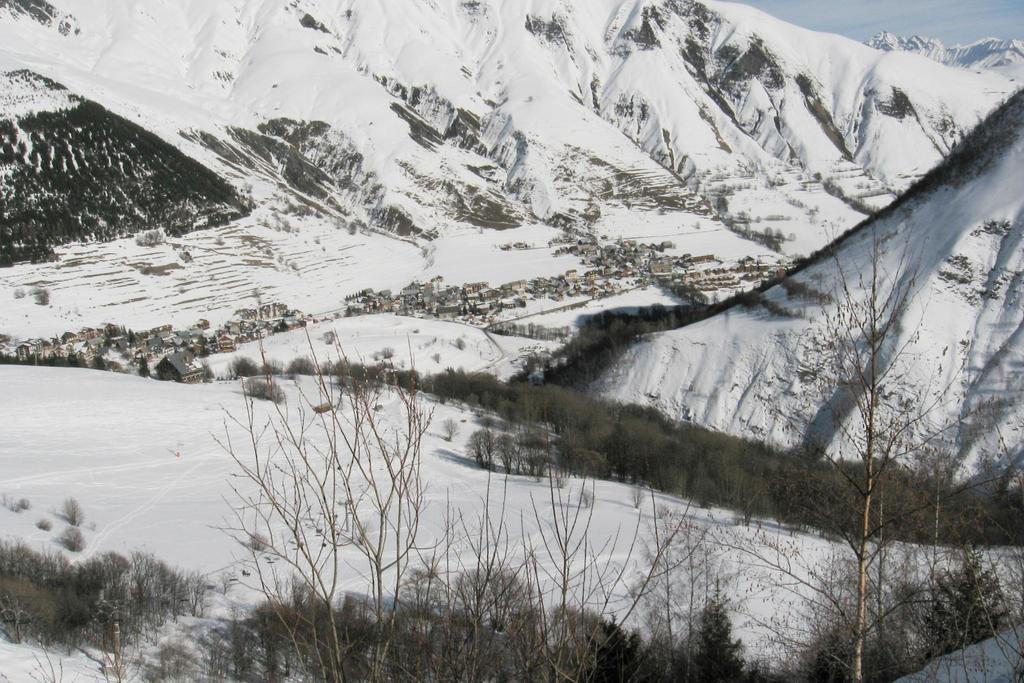Could you give a brief overview of what you see in this image? In this picture we can see ice mountains with bushes, plants and houses. 